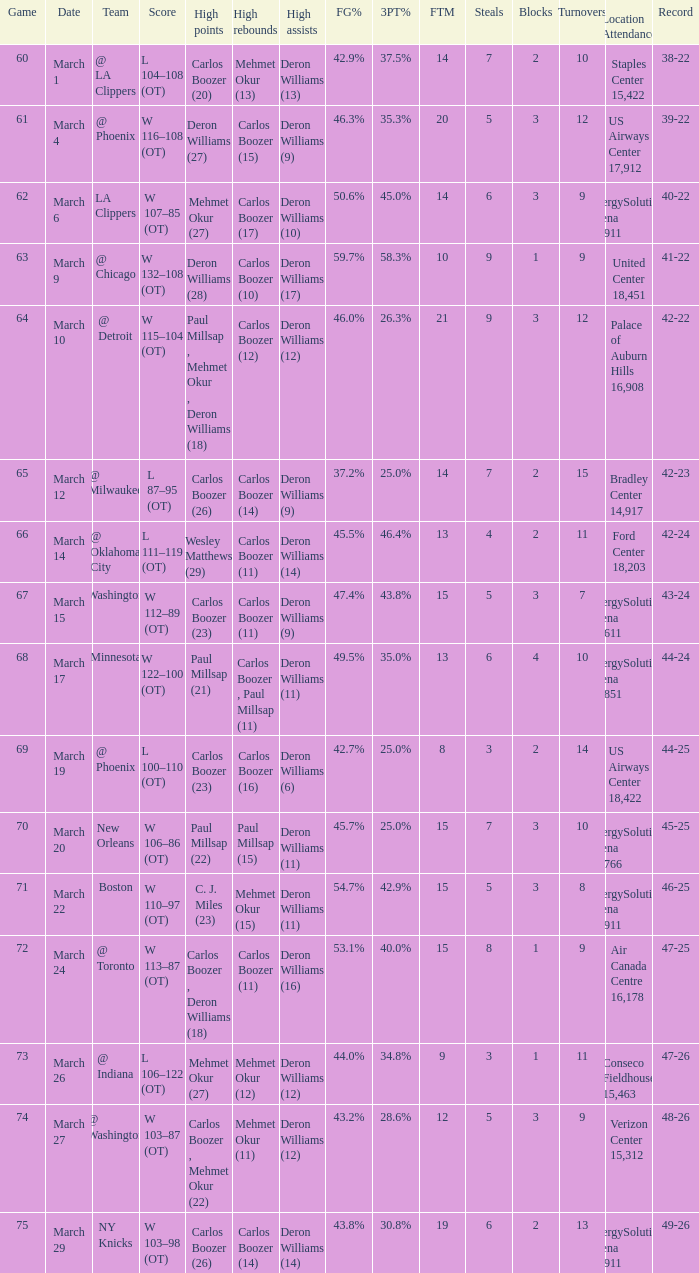What was the record at the game where Deron Williams (6) did the high assists? 44-25. 